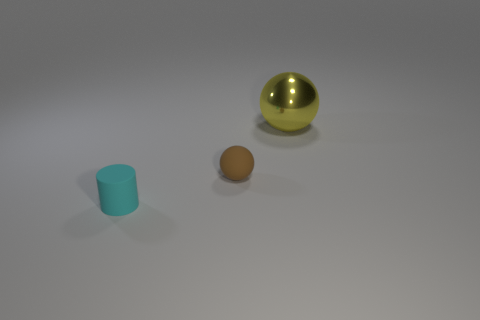Imagine if this scene was part of a learning game for children, what could be a potential exercise involving these objects? A potential learning exercise could involve asking children to sort the objects by size or color. Another possibility would be a spatial awareness game where the children are asked to position objects in a given sequence based on instructions, or even a simple counting game to identify the number of objects, enhancing both their cognitive and motor skills. 